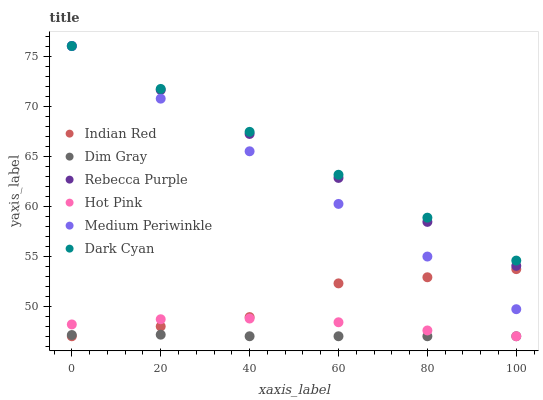Does Dim Gray have the minimum area under the curve?
Answer yes or no. Yes. Does Dark Cyan have the maximum area under the curve?
Answer yes or no. Yes. Does Hot Pink have the minimum area under the curve?
Answer yes or no. No. Does Hot Pink have the maximum area under the curve?
Answer yes or no. No. Is Rebecca Purple the smoothest?
Answer yes or no. Yes. Is Indian Red the roughest?
Answer yes or no. Yes. Is Hot Pink the smoothest?
Answer yes or no. No. Is Hot Pink the roughest?
Answer yes or no. No. Does Dim Gray have the lowest value?
Answer yes or no. Yes. Does Medium Periwinkle have the lowest value?
Answer yes or no. No. Does Dark Cyan have the highest value?
Answer yes or no. Yes. Does Hot Pink have the highest value?
Answer yes or no. No. Is Indian Red less than Rebecca Purple?
Answer yes or no. Yes. Is Rebecca Purple greater than Indian Red?
Answer yes or no. Yes. Does Hot Pink intersect Dim Gray?
Answer yes or no. Yes. Is Hot Pink less than Dim Gray?
Answer yes or no. No. Is Hot Pink greater than Dim Gray?
Answer yes or no. No. Does Indian Red intersect Rebecca Purple?
Answer yes or no. No. 